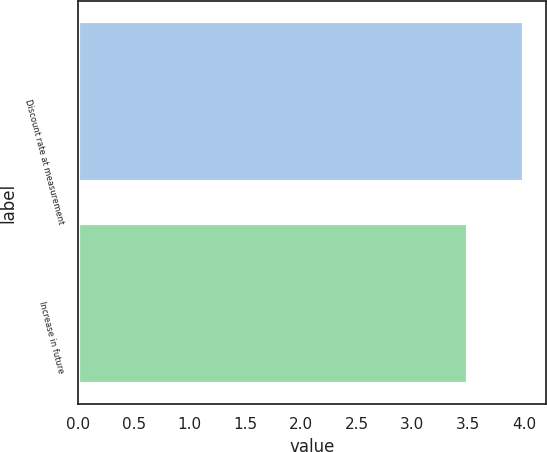Convert chart. <chart><loc_0><loc_0><loc_500><loc_500><bar_chart><fcel>Discount rate at measurement<fcel>Increase in future<nl><fcel>4<fcel>3.5<nl></chart> 